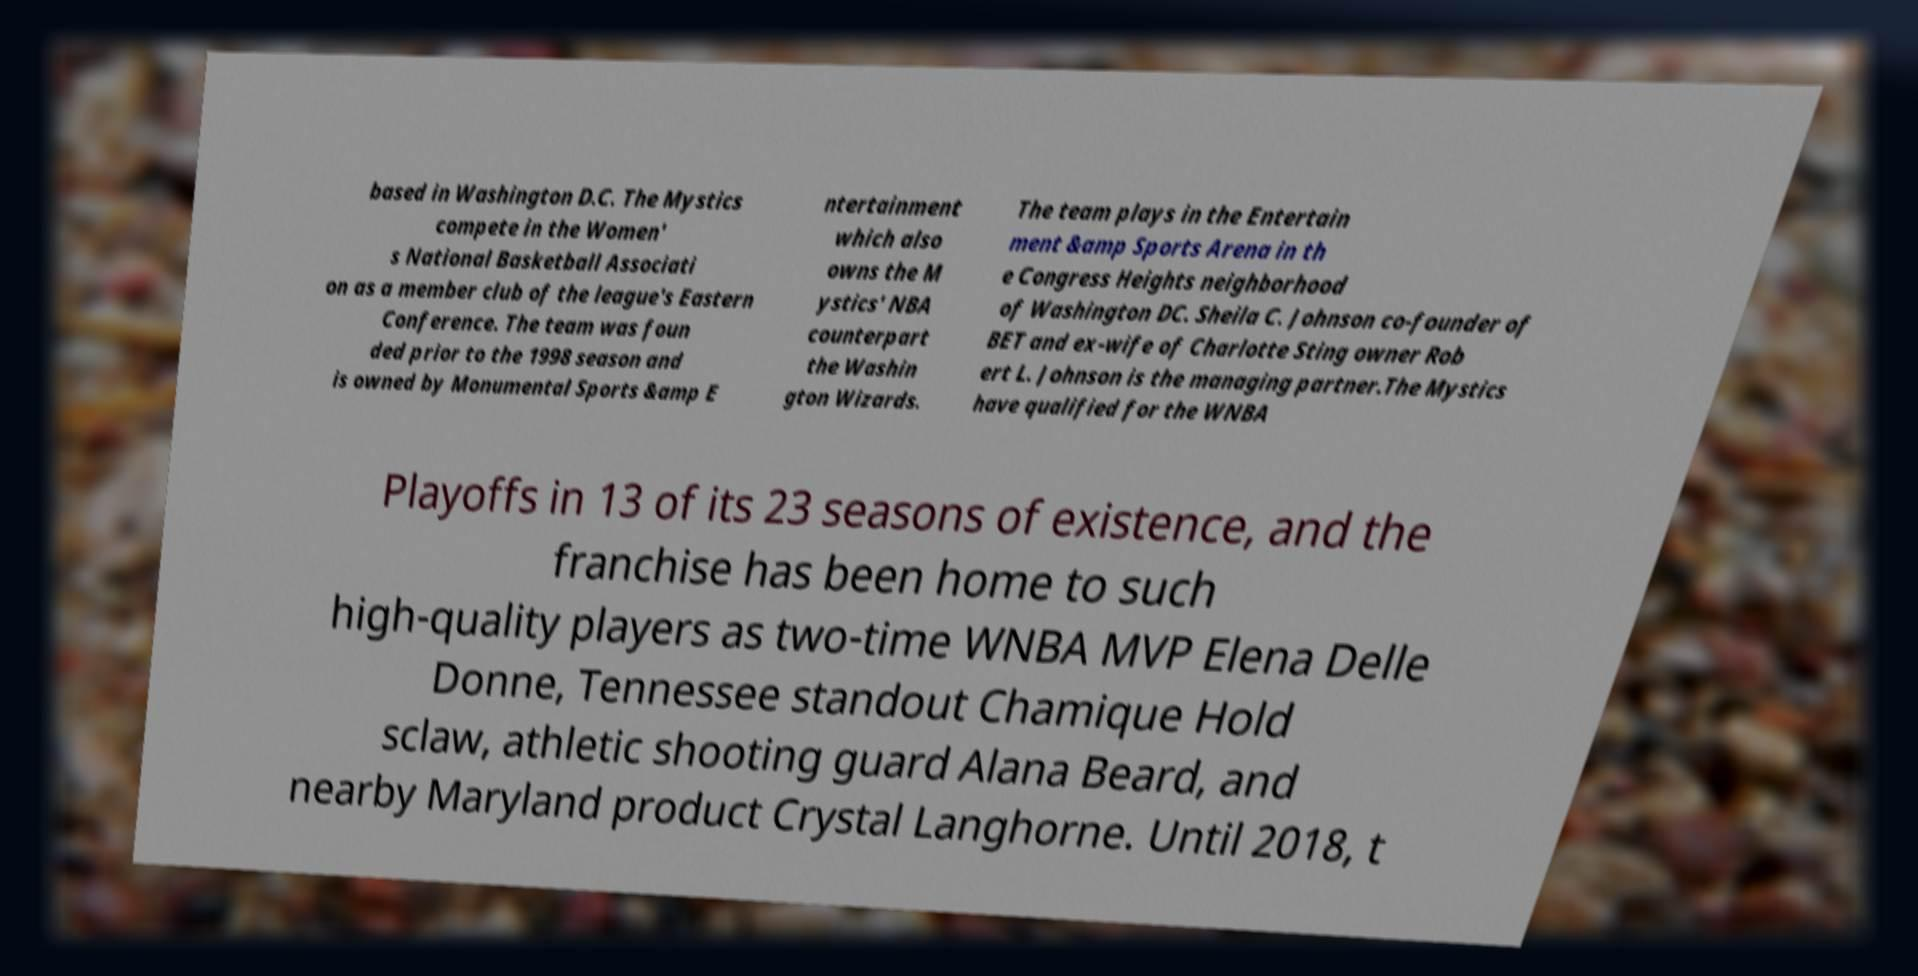Can you read and provide the text displayed in the image?This photo seems to have some interesting text. Can you extract and type it out for me? based in Washington D.C. The Mystics compete in the Women' s National Basketball Associati on as a member club of the league's Eastern Conference. The team was foun ded prior to the 1998 season and is owned by Monumental Sports &amp E ntertainment which also owns the M ystics' NBA counterpart the Washin gton Wizards. The team plays in the Entertain ment &amp Sports Arena in th e Congress Heights neighborhood of Washington DC. Sheila C. Johnson co-founder of BET and ex-wife of Charlotte Sting owner Rob ert L. Johnson is the managing partner.The Mystics have qualified for the WNBA Playoffs in 13 of its 23 seasons of existence, and the franchise has been home to such high-quality players as two-time WNBA MVP Elena Delle Donne, Tennessee standout Chamique Hold sclaw, athletic shooting guard Alana Beard, and nearby Maryland product Crystal Langhorne. Until 2018, t 